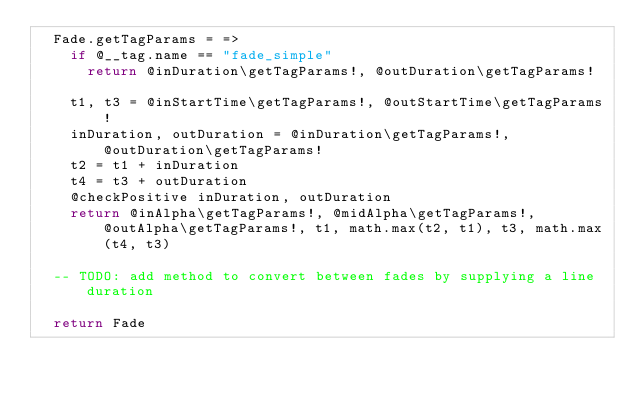Convert code to text. <code><loc_0><loc_0><loc_500><loc_500><_MoonScript_>  Fade.getTagParams = =>
    if @__tag.name == "fade_simple"
      return @inDuration\getTagParams!, @outDuration\getTagParams!

    t1, t3 = @inStartTime\getTagParams!, @outStartTime\getTagParams!
    inDuration, outDuration = @inDuration\getTagParams!, @outDuration\getTagParams!
    t2 = t1 + inDuration
    t4 = t3 + outDuration
    @checkPositive inDuration, outDuration
    return @inAlpha\getTagParams!, @midAlpha\getTagParams!, @outAlpha\getTagParams!, t1, math.max(t2, t1), t3, math.max(t4, t3)

  -- TODO: add method to convert between fades by supplying a line duration

  return Fade
</code> 